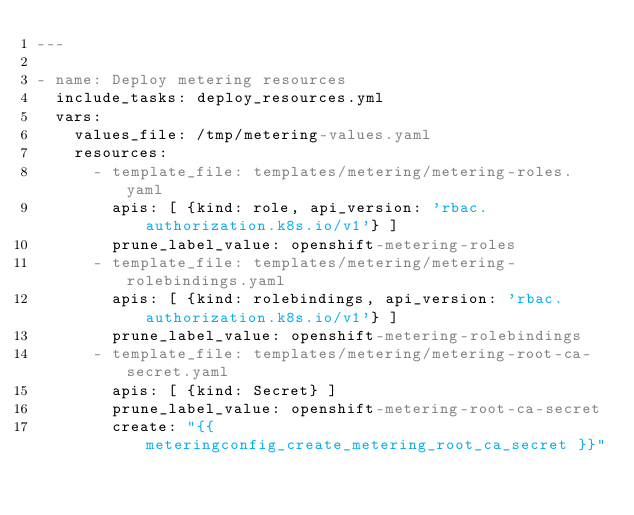<code> <loc_0><loc_0><loc_500><loc_500><_YAML_>---

- name: Deploy metering resources
  include_tasks: deploy_resources.yml
  vars:
    values_file: /tmp/metering-values.yaml
    resources:
      - template_file: templates/metering/metering-roles.yaml
        apis: [ {kind: role, api_version: 'rbac.authorization.k8s.io/v1'} ]
        prune_label_value: openshift-metering-roles
      - template_file: templates/metering/metering-rolebindings.yaml
        apis: [ {kind: rolebindings, api_version: 'rbac.authorization.k8s.io/v1'} ]
        prune_label_value: openshift-metering-rolebindings
      - template_file: templates/metering/metering-root-ca-secret.yaml
        apis: [ {kind: Secret} ]
        prune_label_value: openshift-metering-root-ca-secret
        create: "{{ meteringconfig_create_metering_root_ca_secret }}"
</code> 